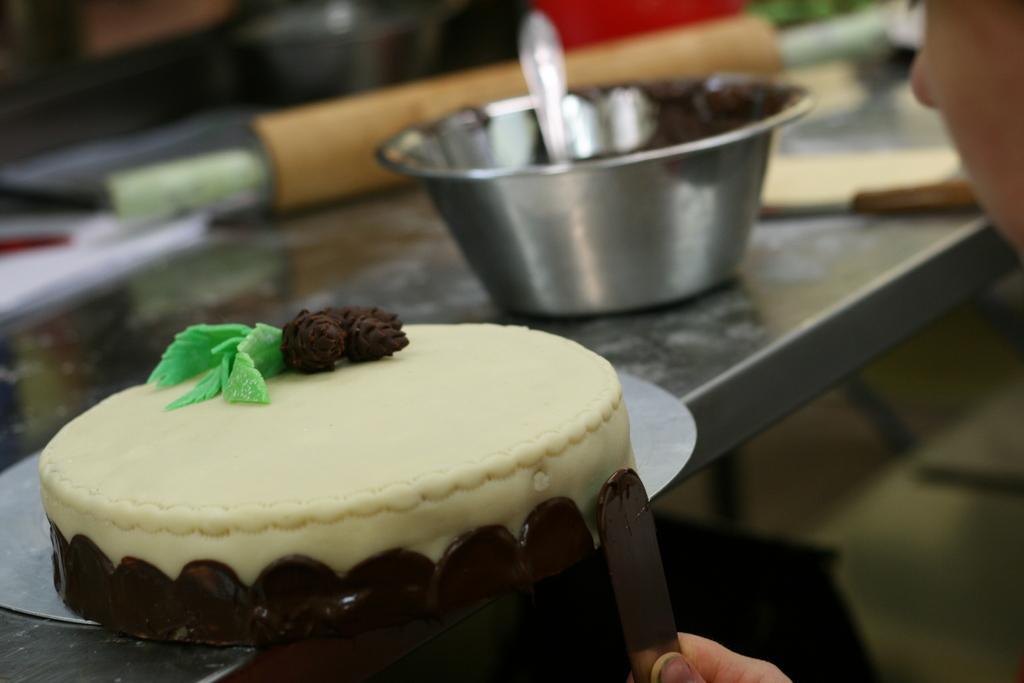Could you give a brief overview of what you see in this image? In the image on the surface there is a round shape plate with a cake on it. There we can see a person hand holding the spoon. Beside the cake there is a bowl with a spoon in it. And in the background there are items and the image is blur in the background.  